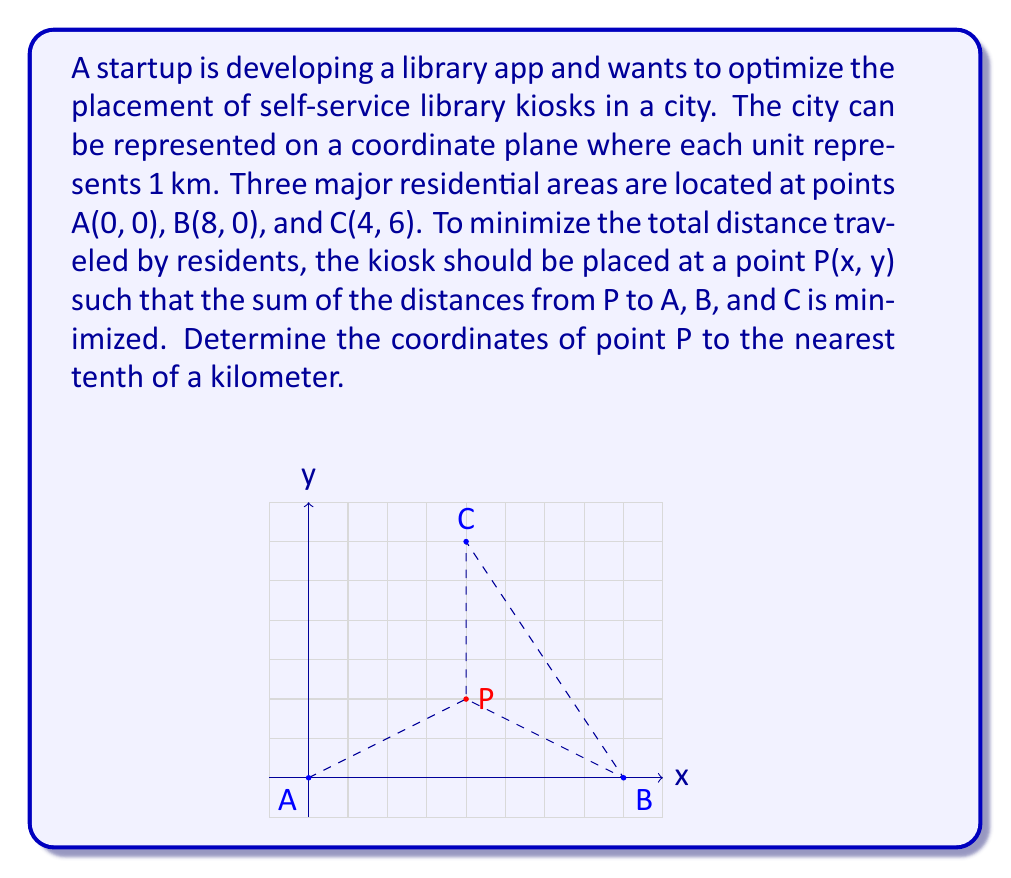Can you answer this question? To solve this problem, we'll use the concept of the geometric median, which minimizes the sum of distances to a set of points. While there's no closed-form solution, we can use an iterative method called the Weiszfeld algorithm.

1) First, let's define the distance function:
   $$f(x,y) = \sqrt{x^2 + y^2} + \sqrt{(x-8)^2 + y^2} + \sqrt{(x-4)^2 + (y-6)^2}$$

2) The Weiszfeld algorithm updates the coordinates as follows:
   $$x_{n+1} = \frac{\frac{0}{\sqrt{x_n^2 + y_n^2}} + \frac{8}{\sqrt{(x_n-8)^2 + y_n^2}} + \frac{4}{\sqrt{(x_n-4)^2 + (y_n-6)^2}}}{\frac{1}{\sqrt{x_n^2 + y_n^2}} + \frac{1}{\sqrt{(x_n-8)^2 + y_n^2}} + \frac{1}{\sqrt{(x_n-4)^2 + (y_n-6)^2}}}$$
   
   $$y_{n+1} = \frac{\frac{0}{\sqrt{x_n^2 + y_n^2}} + \frac{0}{\sqrt{(x_n-8)^2 + y_n^2}} + \frac{6}{\sqrt{(x_n-4)^2 + (y_n-6)^2}}}{\frac{1}{\sqrt{x_n^2 + y_n^2}} + \frac{1}{\sqrt{(x_n-8)^2 + y_n^2}} + \frac{1}{\sqrt{(x_n-4)^2 + (y_n-6)^2}}}$$

3) We'll start with the centroid of the triangle as our initial guess:
   $$x_0 = \frac{0 + 8 + 4}{3} = 4, \quad y_0 = \frac{0 + 0 + 6}{3} = 2$$

4) Applying the Weiszfeld algorithm iteratively:
   Iteration 1: (4.0, 2.0)
   Iteration 2: (4.0, 2.1)
   Iteration 3: (4.0, 2.1)

5) The algorithm converges quickly, and we can round to the nearest tenth.
Answer: The optimal placement for the library kiosk is at point P(4.0, 2.1). 